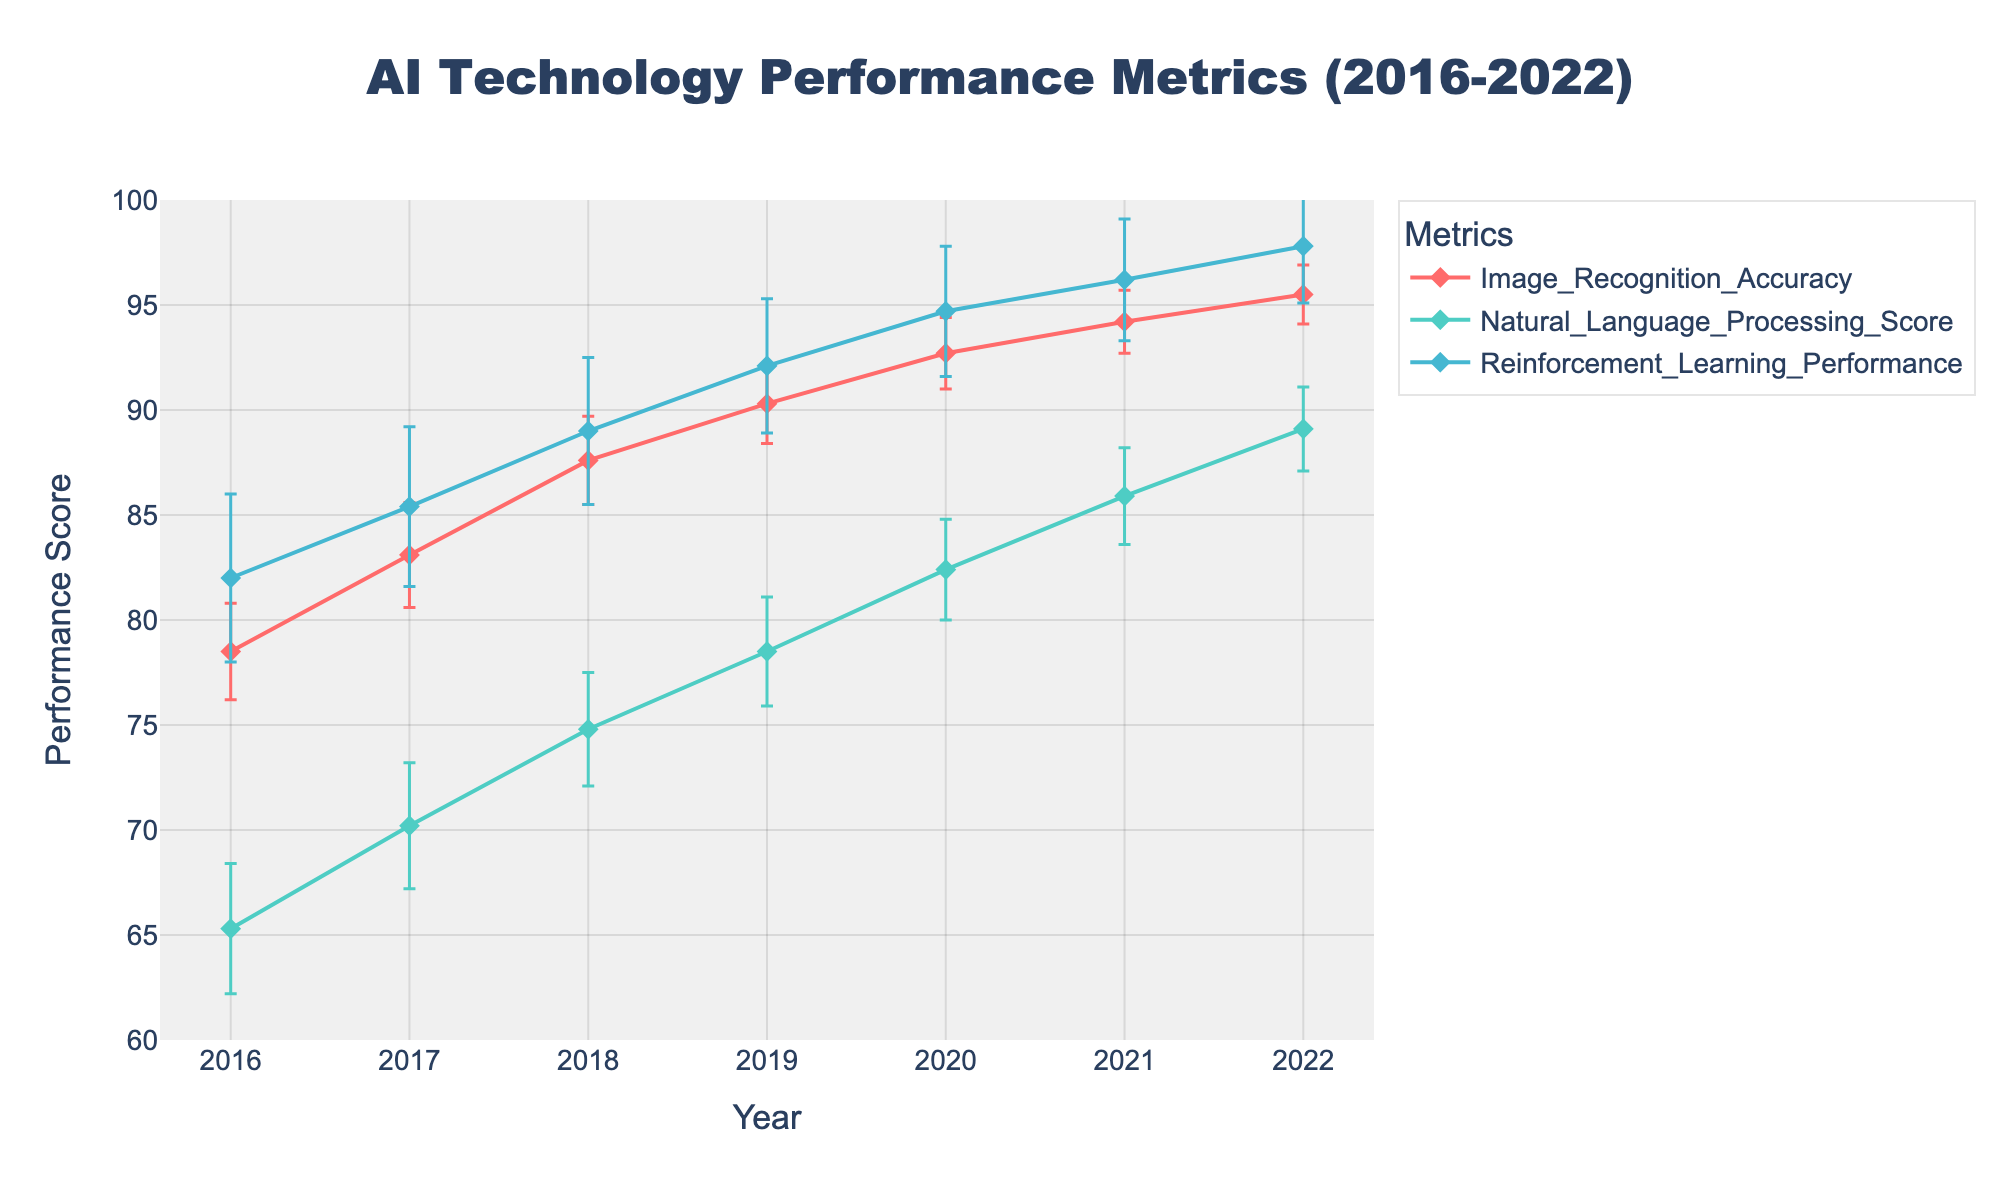What is the title of the figure? The title of the figure is located at the top and is displayed prominently. It provides a brief description of what the figure represents. The title is: 'AI Technology Performance Metrics (2016-2022)'
Answer: AI Technology Performance Metrics (2016-2022) How many different types of AI performance metrics are shown in the figure? By examining the legend or the different lines in the plot, we can see that there are three different types of AI performance metrics represented. These are Image Recognition Accuracy, Natural Language Processing Score, and Reinforcement Learning Performance.
Answer: 3 What metric had the highest improvement from 2016 to 2022? To answer this, calculate the difference between the values for each metric from 2016 to 2022 and identify the largest one. Image Recognition Accuracy improved from 78.5 to 95.5, Natural Language Processing Score from 65.3 to 89.1, and Reinforcement Learning Performance from 82.0 to 97.8. The highest improvement is in Natural Language Processing Score with a difference of 23.8 points.
Answer: Natural Language Processing Score Which year showed the highest performance score for Image Recognition Accuracy? To determine this, look for the peak point in the Image Recognition Accuracy line. The highest score is in 2022 with a value of 95.5.
Answer: 2022 In which year did Natural Language Processing Score have the lowest standard deviation? Look at the error bars for the Natural Language Processing Score in each year. The smallest error bar length represents the lowest standard deviation. For 2022, the error bar for Natural Language Processing Score is the shortest, indicating the lowest standard deviation of 2.0.
Answer: 2022 How did the performance of Reinforcement Learning change from 2018 to 2020? To find this, look at the values for Reinforcement Learning Performance in 2018 and 2020. In 2018, the value was 89.0, and in 2020, it was 94.7. Subtracting these, 94.7 - 89.0, gives an improvement of 5.7 points.
Answer: 5.7 points Compare the standard deviations of Image Recognition Accuracy and Reinforcement Learning Performance in 2019. Which has a larger value? Review the standard deviation values for both metrics in 2019. Image Recognition Accuracy has a standard deviation of 1.9, whereas Reinforcement Learning Performance has a standard deviation of 3.2. Therefore, Reinforcement Learning Performance has a larger standard deviation.
Answer: Reinforcement Learning Performance Which metric consistently improved every year from 2016 to 2022? To answer this, examine the trend for each metric year by year. Image Recognition Accuracy, Natural Language Processing Score, and Reinforcement Learning Performance all show consistent improvement across each year from 2016 to 2022.
Answer: All metrics What is the average performance score for Image Recognition Accuracy from 2016 to 2022? To find the average, sum the values for Image Recognition Accuracy from 2016 to 2022 (78.5 + 83.1 + 87.6 + 90.3 + 92.7 + 94.2 + 95.5) and divide by the number of years, which is 7. The sum is 621.9, so the average is 621.9 / 7 = approximately 88.84.
Answer: Approximately 88.84 